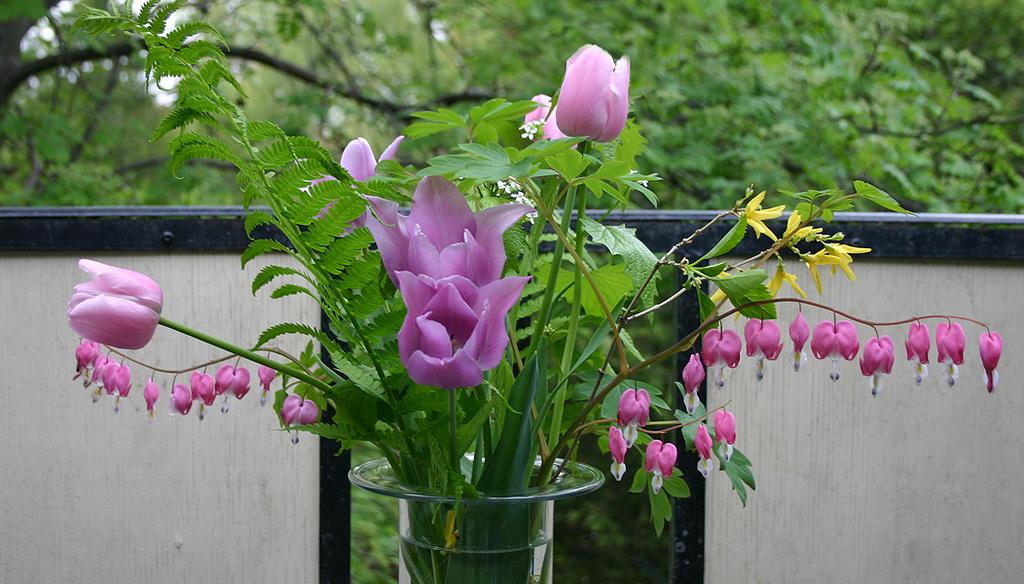What type of flowers can be seen in the image? There are purple color flowers in the image. How are the flowers arranged in the image? The flowers are in a vase. What else is present in the vase besides the flowers? There are plants in the vase. What can be seen in the background of the image? The background of the image is blurred, but a wall and trees are visible. What type of vegetable is being served on a plate in the image? There is no plate or vegetable present in the image; it features purple color flowers in a vase. 